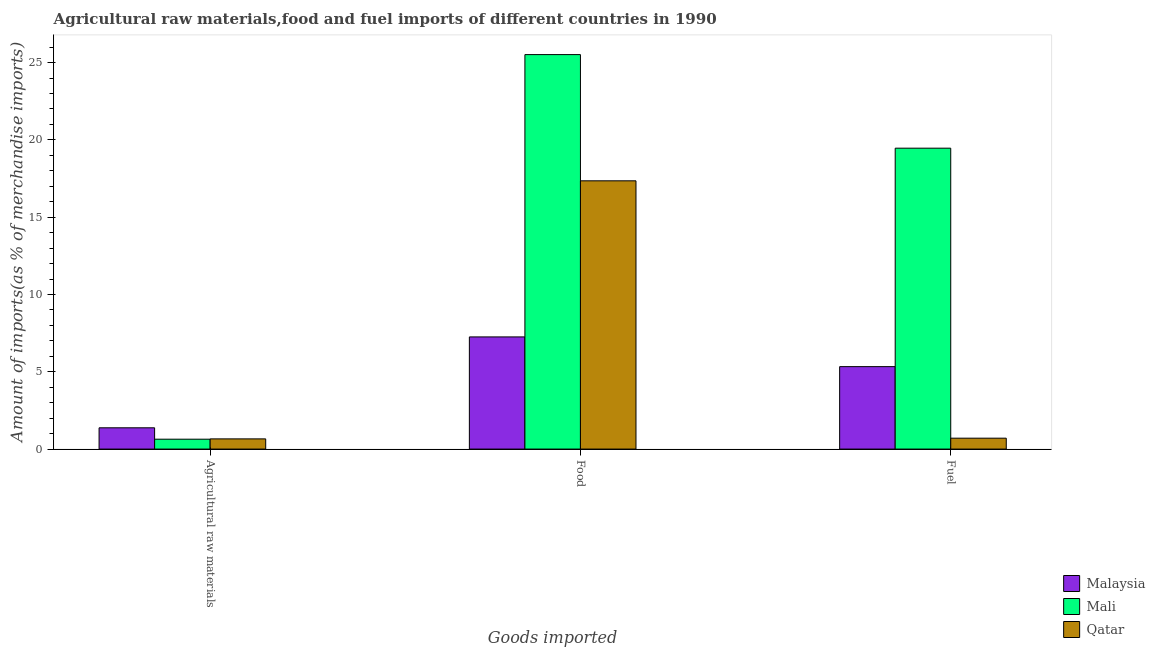Are the number of bars per tick equal to the number of legend labels?
Offer a terse response. Yes. Are the number of bars on each tick of the X-axis equal?
Your response must be concise. Yes. How many bars are there on the 1st tick from the right?
Provide a succinct answer. 3. What is the label of the 1st group of bars from the left?
Provide a short and direct response. Agricultural raw materials. What is the percentage of raw materials imports in Malaysia?
Provide a short and direct response. 1.38. Across all countries, what is the maximum percentage of raw materials imports?
Offer a very short reply. 1.38. Across all countries, what is the minimum percentage of food imports?
Provide a succinct answer. 7.26. In which country was the percentage of fuel imports maximum?
Keep it short and to the point. Mali. In which country was the percentage of food imports minimum?
Keep it short and to the point. Malaysia. What is the total percentage of fuel imports in the graph?
Provide a succinct answer. 25.5. What is the difference between the percentage of fuel imports in Malaysia and that in Qatar?
Keep it short and to the point. 4.63. What is the difference between the percentage of raw materials imports in Malaysia and the percentage of food imports in Qatar?
Provide a short and direct response. -15.98. What is the average percentage of raw materials imports per country?
Offer a terse response. 0.89. What is the difference between the percentage of fuel imports and percentage of raw materials imports in Malaysia?
Your answer should be very brief. 3.96. In how many countries, is the percentage of fuel imports greater than 24 %?
Your answer should be compact. 0. What is the ratio of the percentage of fuel imports in Qatar to that in Mali?
Give a very brief answer. 0.04. Is the difference between the percentage of food imports in Mali and Qatar greater than the difference between the percentage of raw materials imports in Mali and Qatar?
Provide a short and direct response. Yes. What is the difference between the highest and the second highest percentage of raw materials imports?
Offer a very short reply. 0.72. What is the difference between the highest and the lowest percentage of fuel imports?
Make the answer very short. 18.76. What does the 1st bar from the left in Agricultural raw materials represents?
Provide a short and direct response. Malaysia. What does the 2nd bar from the right in Food represents?
Your answer should be very brief. Mali. Is it the case that in every country, the sum of the percentage of raw materials imports and percentage of food imports is greater than the percentage of fuel imports?
Your answer should be compact. Yes. How many countries are there in the graph?
Your answer should be very brief. 3. What is the difference between two consecutive major ticks on the Y-axis?
Offer a terse response. 5. How many legend labels are there?
Ensure brevity in your answer.  3. What is the title of the graph?
Give a very brief answer. Agricultural raw materials,food and fuel imports of different countries in 1990. What is the label or title of the X-axis?
Keep it short and to the point. Goods imported. What is the label or title of the Y-axis?
Your answer should be compact. Amount of imports(as % of merchandise imports). What is the Amount of imports(as % of merchandise imports) in Malaysia in Agricultural raw materials?
Your response must be concise. 1.38. What is the Amount of imports(as % of merchandise imports) of Mali in Agricultural raw materials?
Provide a succinct answer. 0.64. What is the Amount of imports(as % of merchandise imports) in Qatar in Agricultural raw materials?
Offer a terse response. 0.66. What is the Amount of imports(as % of merchandise imports) of Malaysia in Food?
Provide a short and direct response. 7.26. What is the Amount of imports(as % of merchandise imports) of Mali in Food?
Keep it short and to the point. 25.52. What is the Amount of imports(as % of merchandise imports) of Qatar in Food?
Give a very brief answer. 17.35. What is the Amount of imports(as % of merchandise imports) in Malaysia in Fuel?
Provide a short and direct response. 5.33. What is the Amount of imports(as % of merchandise imports) of Mali in Fuel?
Give a very brief answer. 19.46. What is the Amount of imports(as % of merchandise imports) of Qatar in Fuel?
Provide a succinct answer. 0.7. Across all Goods imported, what is the maximum Amount of imports(as % of merchandise imports) in Malaysia?
Your answer should be compact. 7.26. Across all Goods imported, what is the maximum Amount of imports(as % of merchandise imports) in Mali?
Give a very brief answer. 25.52. Across all Goods imported, what is the maximum Amount of imports(as % of merchandise imports) of Qatar?
Offer a very short reply. 17.35. Across all Goods imported, what is the minimum Amount of imports(as % of merchandise imports) of Malaysia?
Your answer should be very brief. 1.38. Across all Goods imported, what is the minimum Amount of imports(as % of merchandise imports) of Mali?
Provide a succinct answer. 0.64. Across all Goods imported, what is the minimum Amount of imports(as % of merchandise imports) of Qatar?
Your answer should be very brief. 0.66. What is the total Amount of imports(as % of merchandise imports) in Malaysia in the graph?
Ensure brevity in your answer.  13.96. What is the total Amount of imports(as % of merchandise imports) in Mali in the graph?
Your response must be concise. 45.62. What is the total Amount of imports(as % of merchandise imports) of Qatar in the graph?
Ensure brevity in your answer.  18.71. What is the difference between the Amount of imports(as % of merchandise imports) of Malaysia in Agricultural raw materials and that in Food?
Give a very brief answer. -5.88. What is the difference between the Amount of imports(as % of merchandise imports) of Mali in Agricultural raw materials and that in Food?
Keep it short and to the point. -24.88. What is the difference between the Amount of imports(as % of merchandise imports) in Qatar in Agricultural raw materials and that in Food?
Provide a short and direct response. -16.69. What is the difference between the Amount of imports(as % of merchandise imports) in Malaysia in Agricultural raw materials and that in Fuel?
Keep it short and to the point. -3.96. What is the difference between the Amount of imports(as % of merchandise imports) of Mali in Agricultural raw materials and that in Fuel?
Your response must be concise. -18.82. What is the difference between the Amount of imports(as % of merchandise imports) of Qatar in Agricultural raw materials and that in Fuel?
Your response must be concise. -0.05. What is the difference between the Amount of imports(as % of merchandise imports) of Malaysia in Food and that in Fuel?
Keep it short and to the point. 1.92. What is the difference between the Amount of imports(as % of merchandise imports) in Mali in Food and that in Fuel?
Your answer should be compact. 6.05. What is the difference between the Amount of imports(as % of merchandise imports) of Qatar in Food and that in Fuel?
Your answer should be compact. 16.65. What is the difference between the Amount of imports(as % of merchandise imports) in Malaysia in Agricultural raw materials and the Amount of imports(as % of merchandise imports) in Mali in Food?
Your answer should be compact. -24.14. What is the difference between the Amount of imports(as % of merchandise imports) in Malaysia in Agricultural raw materials and the Amount of imports(as % of merchandise imports) in Qatar in Food?
Provide a succinct answer. -15.98. What is the difference between the Amount of imports(as % of merchandise imports) of Mali in Agricultural raw materials and the Amount of imports(as % of merchandise imports) of Qatar in Food?
Your answer should be compact. -16.71. What is the difference between the Amount of imports(as % of merchandise imports) of Malaysia in Agricultural raw materials and the Amount of imports(as % of merchandise imports) of Mali in Fuel?
Offer a very short reply. -18.09. What is the difference between the Amount of imports(as % of merchandise imports) in Malaysia in Agricultural raw materials and the Amount of imports(as % of merchandise imports) in Qatar in Fuel?
Provide a succinct answer. 0.67. What is the difference between the Amount of imports(as % of merchandise imports) of Mali in Agricultural raw materials and the Amount of imports(as % of merchandise imports) of Qatar in Fuel?
Offer a terse response. -0.07. What is the difference between the Amount of imports(as % of merchandise imports) of Malaysia in Food and the Amount of imports(as % of merchandise imports) of Mali in Fuel?
Offer a very short reply. -12.21. What is the difference between the Amount of imports(as % of merchandise imports) of Malaysia in Food and the Amount of imports(as % of merchandise imports) of Qatar in Fuel?
Make the answer very short. 6.55. What is the difference between the Amount of imports(as % of merchandise imports) in Mali in Food and the Amount of imports(as % of merchandise imports) in Qatar in Fuel?
Your response must be concise. 24.81. What is the average Amount of imports(as % of merchandise imports) of Malaysia per Goods imported?
Keep it short and to the point. 4.65. What is the average Amount of imports(as % of merchandise imports) in Mali per Goods imported?
Offer a terse response. 15.21. What is the average Amount of imports(as % of merchandise imports) in Qatar per Goods imported?
Offer a terse response. 6.24. What is the difference between the Amount of imports(as % of merchandise imports) of Malaysia and Amount of imports(as % of merchandise imports) of Mali in Agricultural raw materials?
Your answer should be very brief. 0.74. What is the difference between the Amount of imports(as % of merchandise imports) of Malaysia and Amount of imports(as % of merchandise imports) of Qatar in Agricultural raw materials?
Provide a succinct answer. 0.72. What is the difference between the Amount of imports(as % of merchandise imports) in Mali and Amount of imports(as % of merchandise imports) in Qatar in Agricultural raw materials?
Your response must be concise. -0.02. What is the difference between the Amount of imports(as % of merchandise imports) in Malaysia and Amount of imports(as % of merchandise imports) in Mali in Food?
Offer a very short reply. -18.26. What is the difference between the Amount of imports(as % of merchandise imports) of Malaysia and Amount of imports(as % of merchandise imports) of Qatar in Food?
Offer a very short reply. -10.1. What is the difference between the Amount of imports(as % of merchandise imports) in Mali and Amount of imports(as % of merchandise imports) in Qatar in Food?
Give a very brief answer. 8.16. What is the difference between the Amount of imports(as % of merchandise imports) of Malaysia and Amount of imports(as % of merchandise imports) of Mali in Fuel?
Offer a very short reply. -14.13. What is the difference between the Amount of imports(as % of merchandise imports) of Malaysia and Amount of imports(as % of merchandise imports) of Qatar in Fuel?
Your answer should be compact. 4.63. What is the difference between the Amount of imports(as % of merchandise imports) in Mali and Amount of imports(as % of merchandise imports) in Qatar in Fuel?
Provide a succinct answer. 18.76. What is the ratio of the Amount of imports(as % of merchandise imports) in Malaysia in Agricultural raw materials to that in Food?
Your answer should be compact. 0.19. What is the ratio of the Amount of imports(as % of merchandise imports) of Mali in Agricultural raw materials to that in Food?
Keep it short and to the point. 0.03. What is the ratio of the Amount of imports(as % of merchandise imports) in Qatar in Agricultural raw materials to that in Food?
Give a very brief answer. 0.04. What is the ratio of the Amount of imports(as % of merchandise imports) of Malaysia in Agricultural raw materials to that in Fuel?
Offer a very short reply. 0.26. What is the ratio of the Amount of imports(as % of merchandise imports) in Mali in Agricultural raw materials to that in Fuel?
Provide a short and direct response. 0.03. What is the ratio of the Amount of imports(as % of merchandise imports) of Qatar in Agricultural raw materials to that in Fuel?
Your response must be concise. 0.94. What is the ratio of the Amount of imports(as % of merchandise imports) in Malaysia in Food to that in Fuel?
Keep it short and to the point. 1.36. What is the ratio of the Amount of imports(as % of merchandise imports) in Mali in Food to that in Fuel?
Provide a short and direct response. 1.31. What is the ratio of the Amount of imports(as % of merchandise imports) of Qatar in Food to that in Fuel?
Ensure brevity in your answer.  24.63. What is the difference between the highest and the second highest Amount of imports(as % of merchandise imports) in Malaysia?
Offer a very short reply. 1.92. What is the difference between the highest and the second highest Amount of imports(as % of merchandise imports) in Mali?
Your response must be concise. 6.05. What is the difference between the highest and the second highest Amount of imports(as % of merchandise imports) of Qatar?
Offer a terse response. 16.65. What is the difference between the highest and the lowest Amount of imports(as % of merchandise imports) of Malaysia?
Offer a terse response. 5.88. What is the difference between the highest and the lowest Amount of imports(as % of merchandise imports) of Mali?
Offer a very short reply. 24.88. What is the difference between the highest and the lowest Amount of imports(as % of merchandise imports) in Qatar?
Make the answer very short. 16.69. 